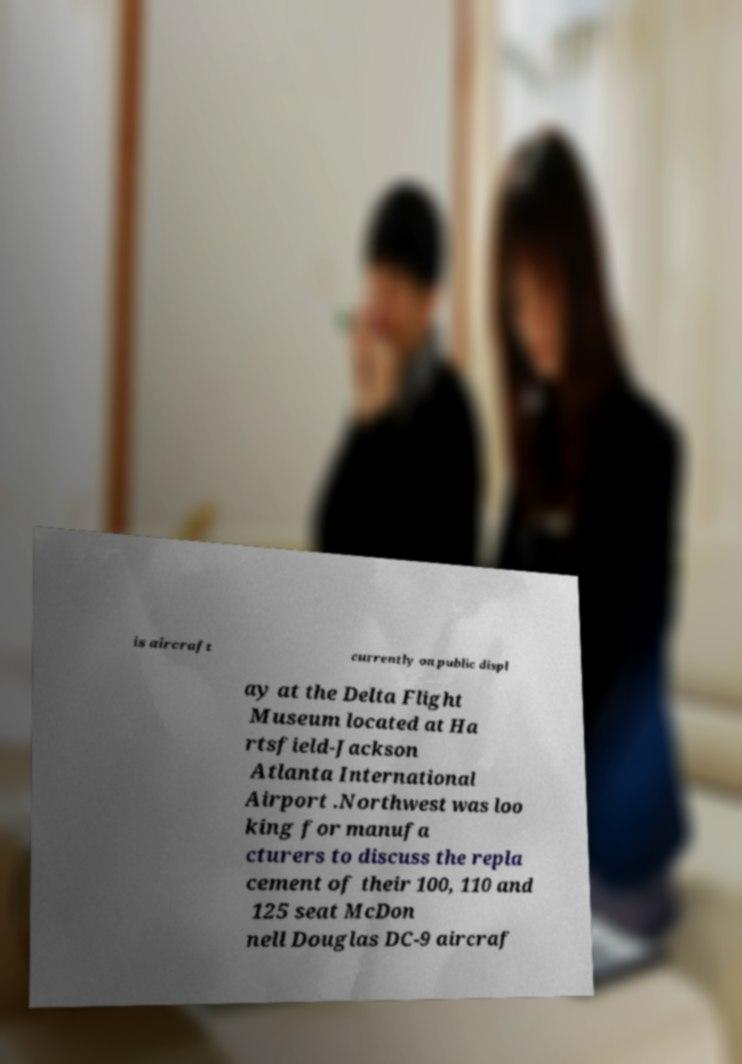Can you accurately transcribe the text from the provided image for me? is aircraft currently on public displ ay at the Delta Flight Museum located at Ha rtsfield-Jackson Atlanta International Airport .Northwest was loo king for manufa cturers to discuss the repla cement of their 100, 110 and 125 seat McDon nell Douglas DC-9 aircraf 